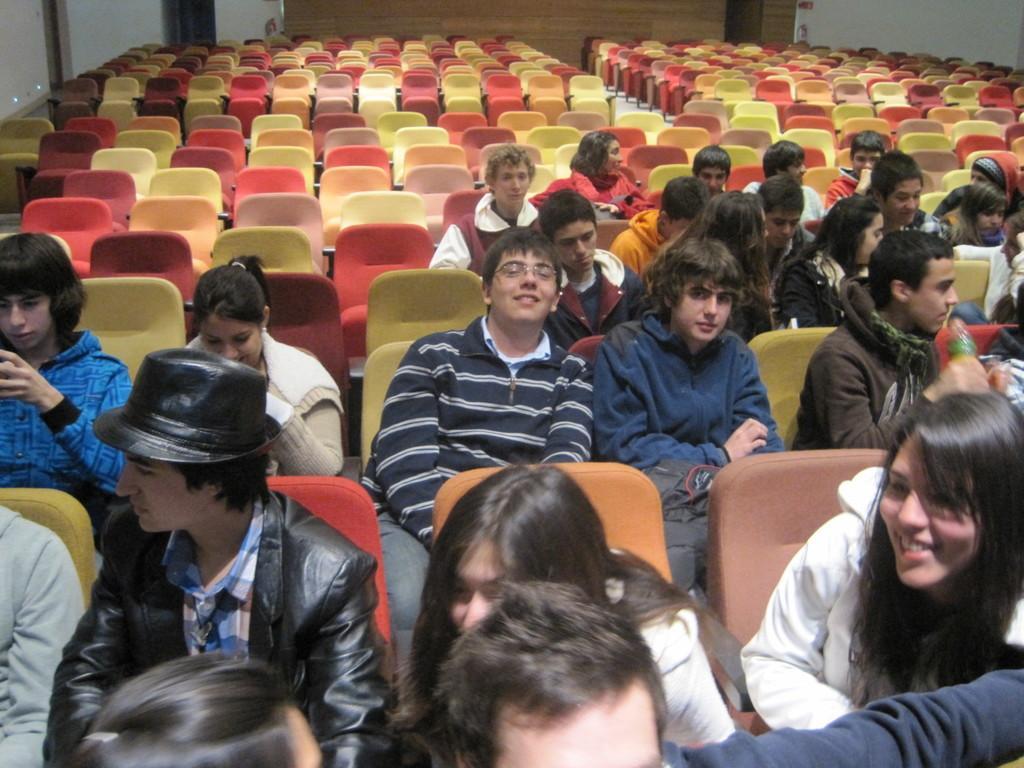How would you summarize this image in a sentence or two? In the center of the image we can see people sitting in the chairs. In the background there is a wall and we can see some chairs. 